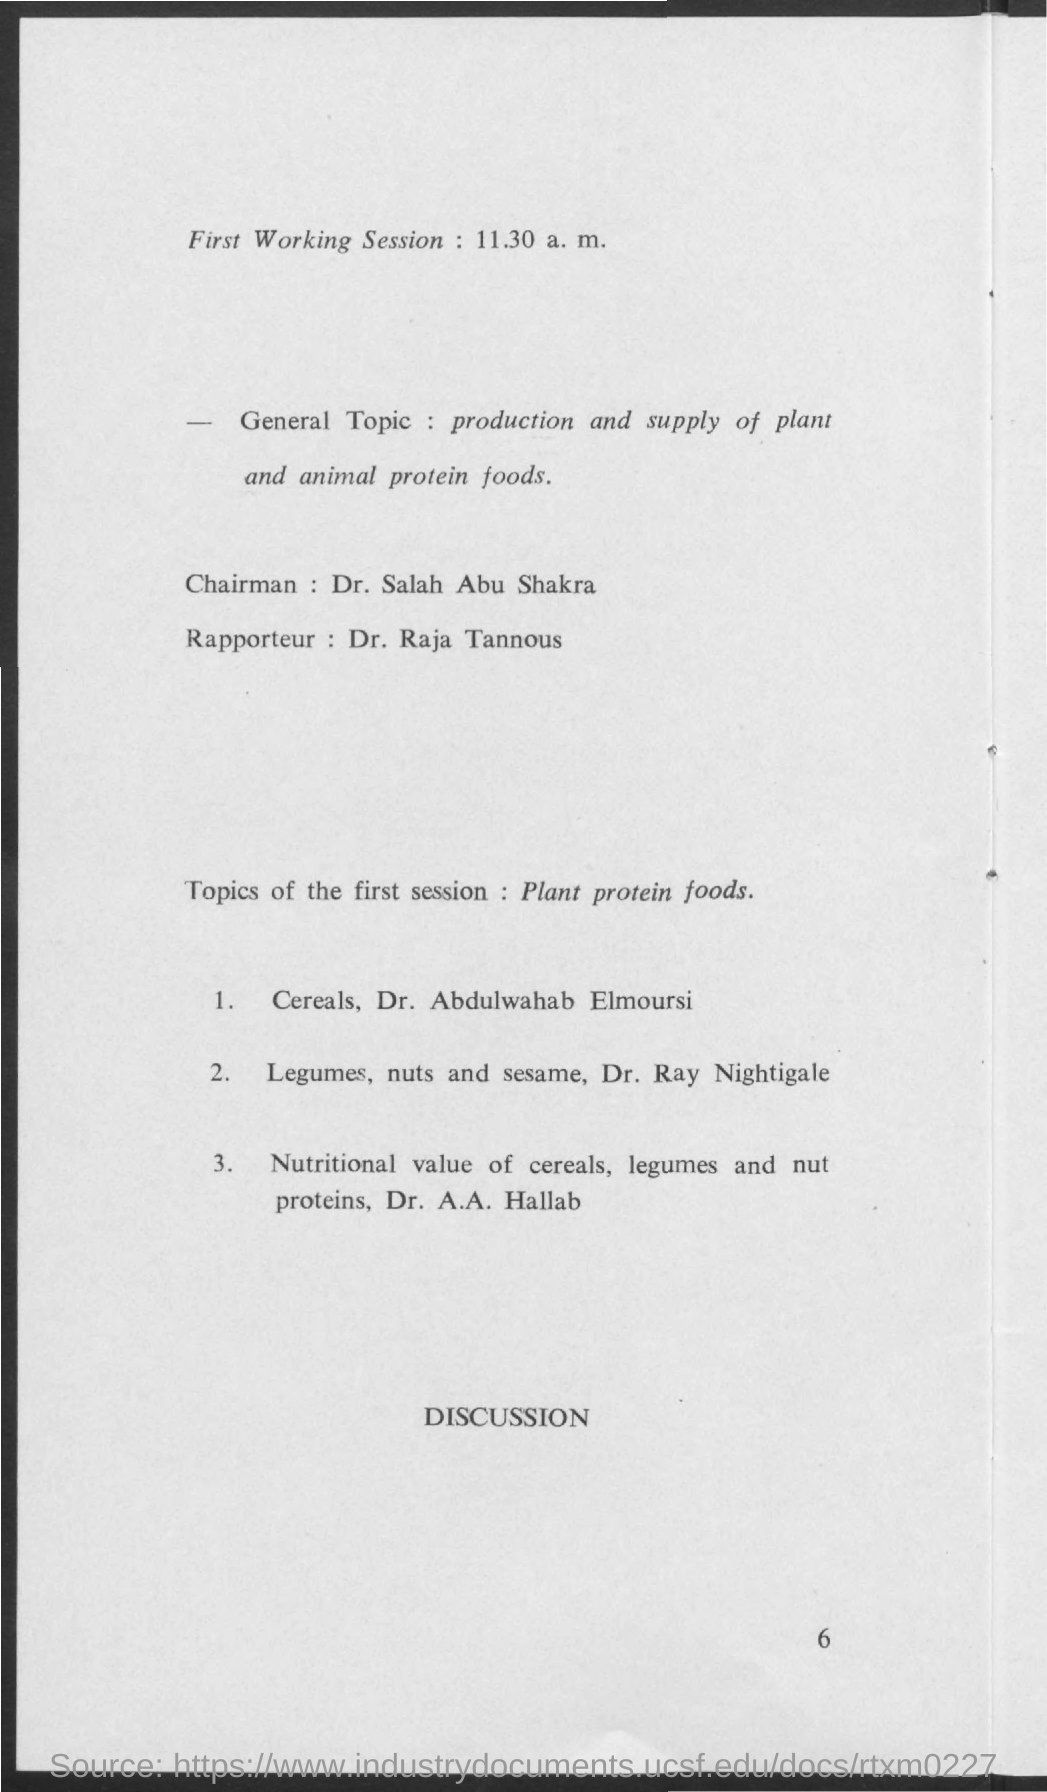Indicate a few pertinent items in this graphic. The general topic mentioned is the production and supply of plant and animal protein foods. The chairman's name is Dr. Salah Abu Shakra. The rapporteur's name is Dr. Raja Tannous. 